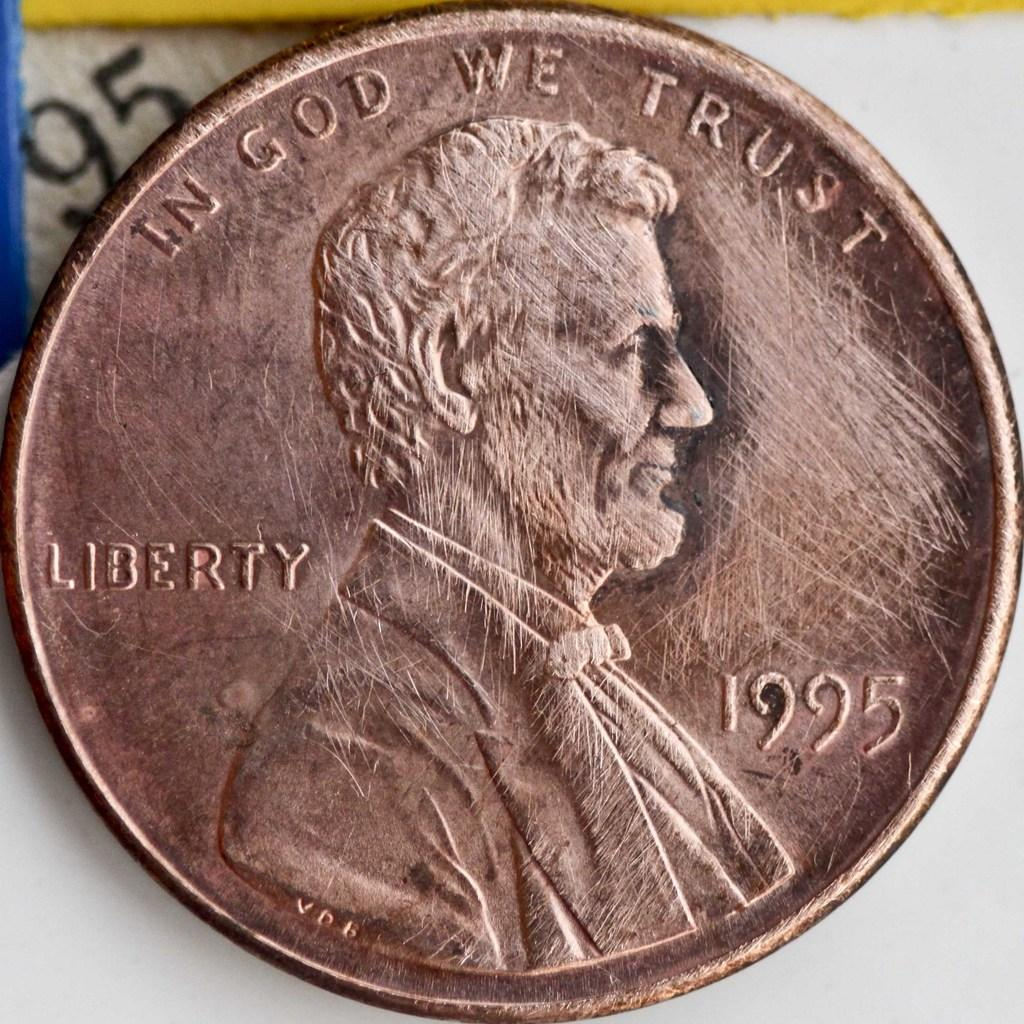<image>
Offer a succinct explanation of the picture presented. A clean penny from 1995 that has the phrases "Liberty" and "In God We Trust" on it. 